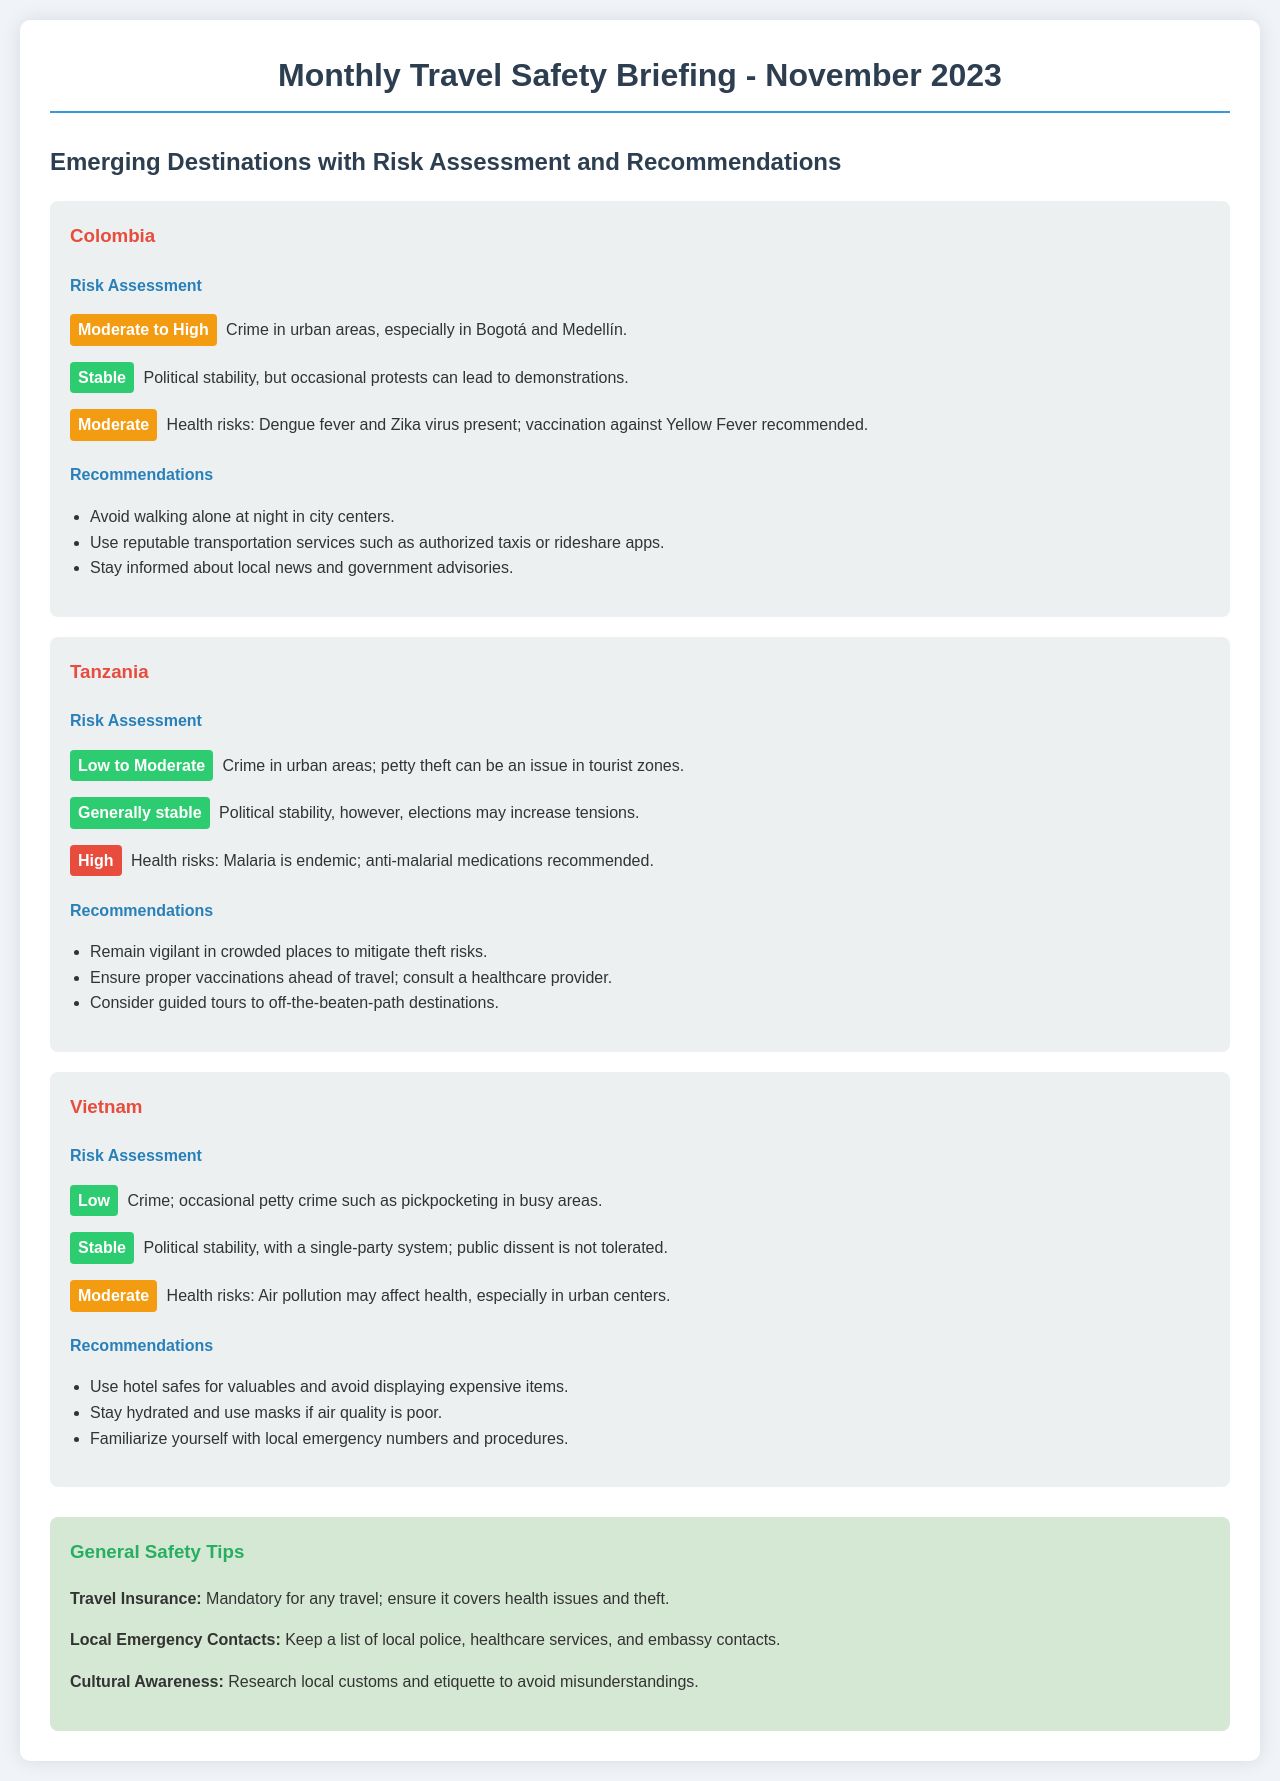What is the title of the document? The document is titled "Monthly Travel Safety Briefing - November 2023."
Answer: Monthly Travel Safety Briefing - November 2023 Which country has a moderate to high risk assessment? The risk assessment for Colombia indicates a moderate to high level of risk.
Answer: Colombia What health risk is specifically mentioned for Tanzania? The document states that malaria is endemic in Tanzania, making it a high health risk.
Answer: Malaria What is the recommended action for Colombia regarding transportation? The document recommends using reputable transportation services such as authorized taxis or rideshare apps in Colombia.
Answer: Use reputable transportation services What is the political stability rating for Vietnam? The document indicates that Vietnam has a stable political situation.
Answer: Stable In which destination is dengue fever a health concern? The document specifies that dengue fever is a health concern in Colombia.
Answer: Colombia What color represents low risk in the document? The color that represents low risk in the document is green.
Answer: Green How does the document advise travelers to safeguard their valuables in Vietnam? It advises travelers to use hotel safes for valuables and avoid displaying expensive items.
Answer: Use hotel safes for valuables Which general safety tip is mentioned regarding travel insurance? The document states that travel insurance is mandatory for any travel.
Answer: Mandatory for any travel 